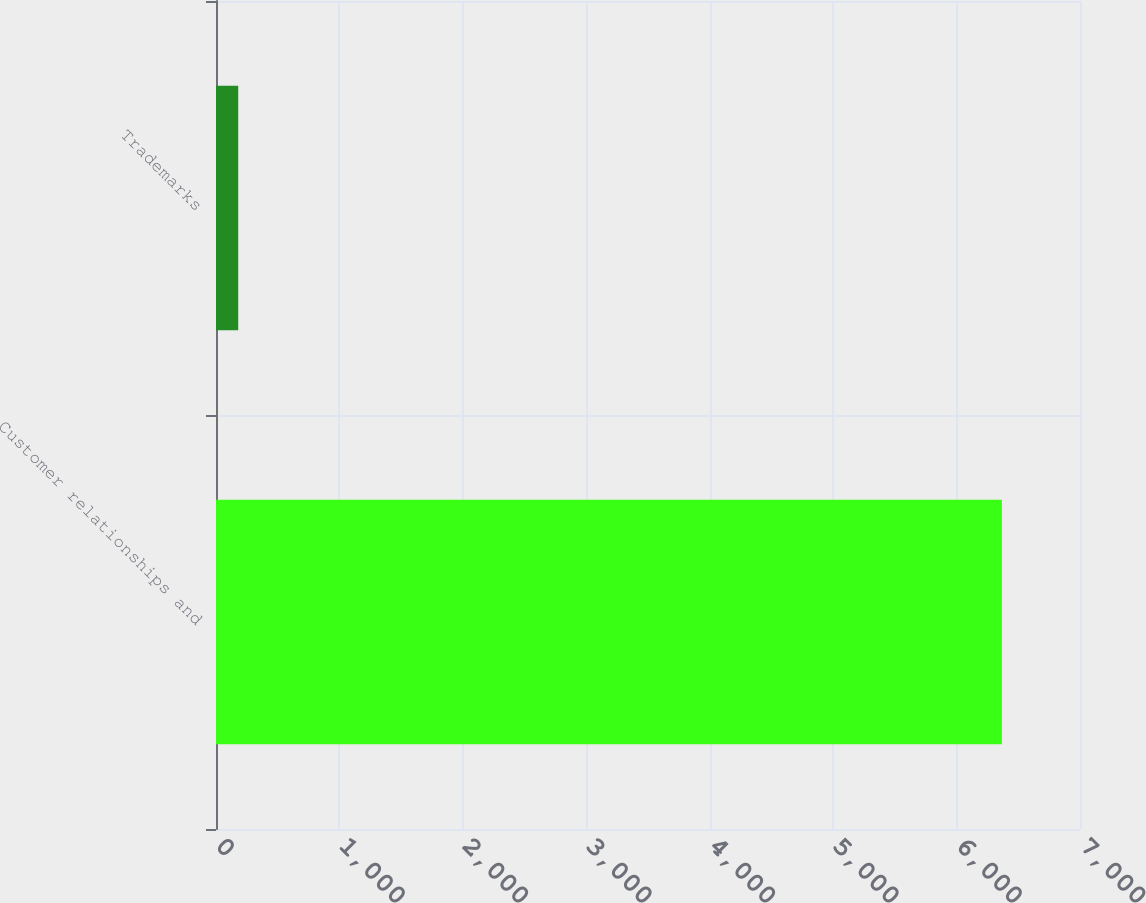Convert chart. <chart><loc_0><loc_0><loc_500><loc_500><bar_chart><fcel>Customer relationships and<fcel>Trademarks<nl><fcel>6367<fcel>180<nl></chart> 